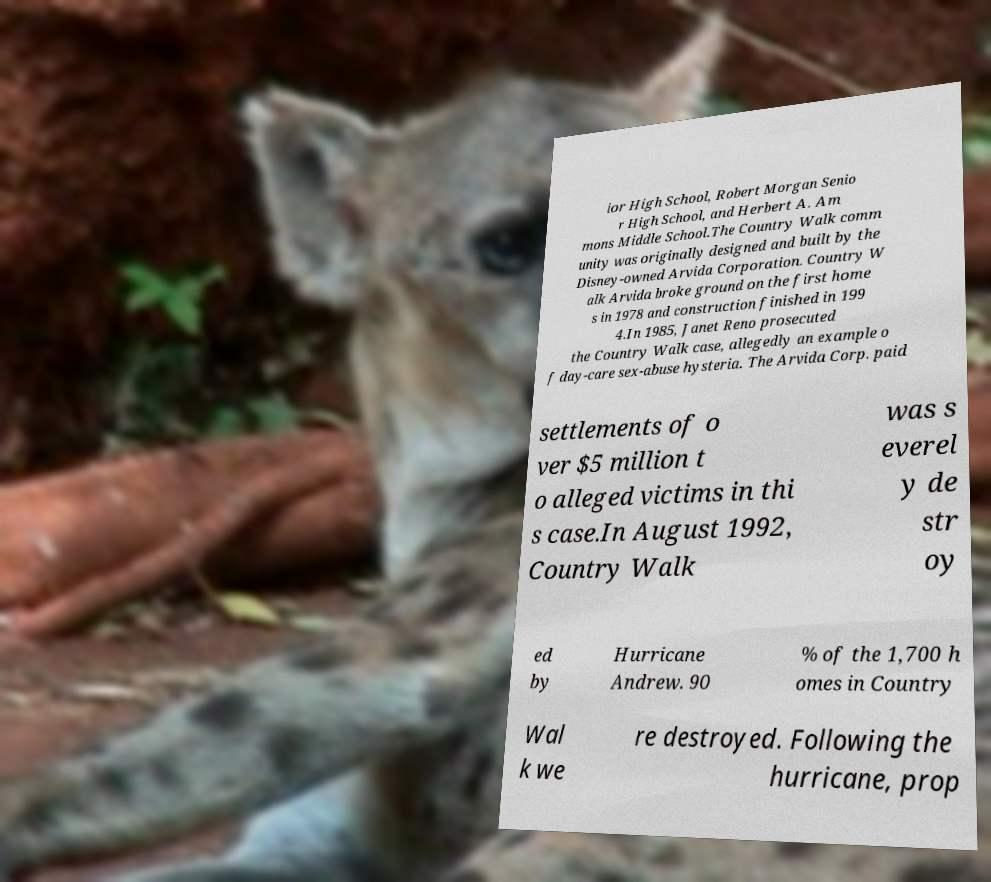I need the written content from this picture converted into text. Can you do that? ior High School, Robert Morgan Senio r High School, and Herbert A. Am mons Middle School.The Country Walk comm unity was originally designed and built by the Disney-owned Arvida Corporation. Country W alk Arvida broke ground on the first home s in 1978 and construction finished in 199 4.In 1985, Janet Reno prosecuted the Country Walk case, allegedly an example o f day-care sex-abuse hysteria. The Arvida Corp. paid settlements of o ver $5 million t o alleged victims in thi s case.In August 1992, Country Walk was s everel y de str oy ed by Hurricane Andrew. 90 % of the 1,700 h omes in Country Wal k we re destroyed. Following the hurricane, prop 